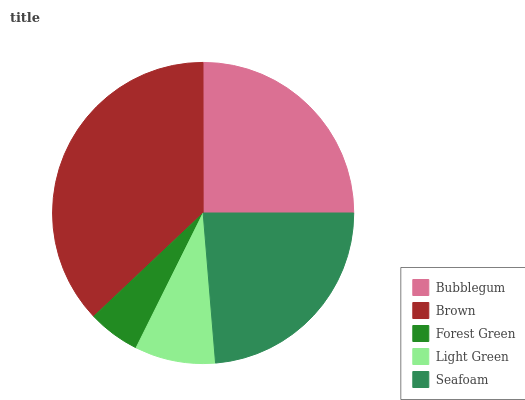Is Forest Green the minimum?
Answer yes or no. Yes. Is Brown the maximum?
Answer yes or no. Yes. Is Brown the minimum?
Answer yes or no. No. Is Forest Green the maximum?
Answer yes or no. No. Is Brown greater than Forest Green?
Answer yes or no. Yes. Is Forest Green less than Brown?
Answer yes or no. Yes. Is Forest Green greater than Brown?
Answer yes or no. No. Is Brown less than Forest Green?
Answer yes or no. No. Is Seafoam the high median?
Answer yes or no. Yes. Is Seafoam the low median?
Answer yes or no. Yes. Is Forest Green the high median?
Answer yes or no. No. Is Bubblegum the low median?
Answer yes or no. No. 